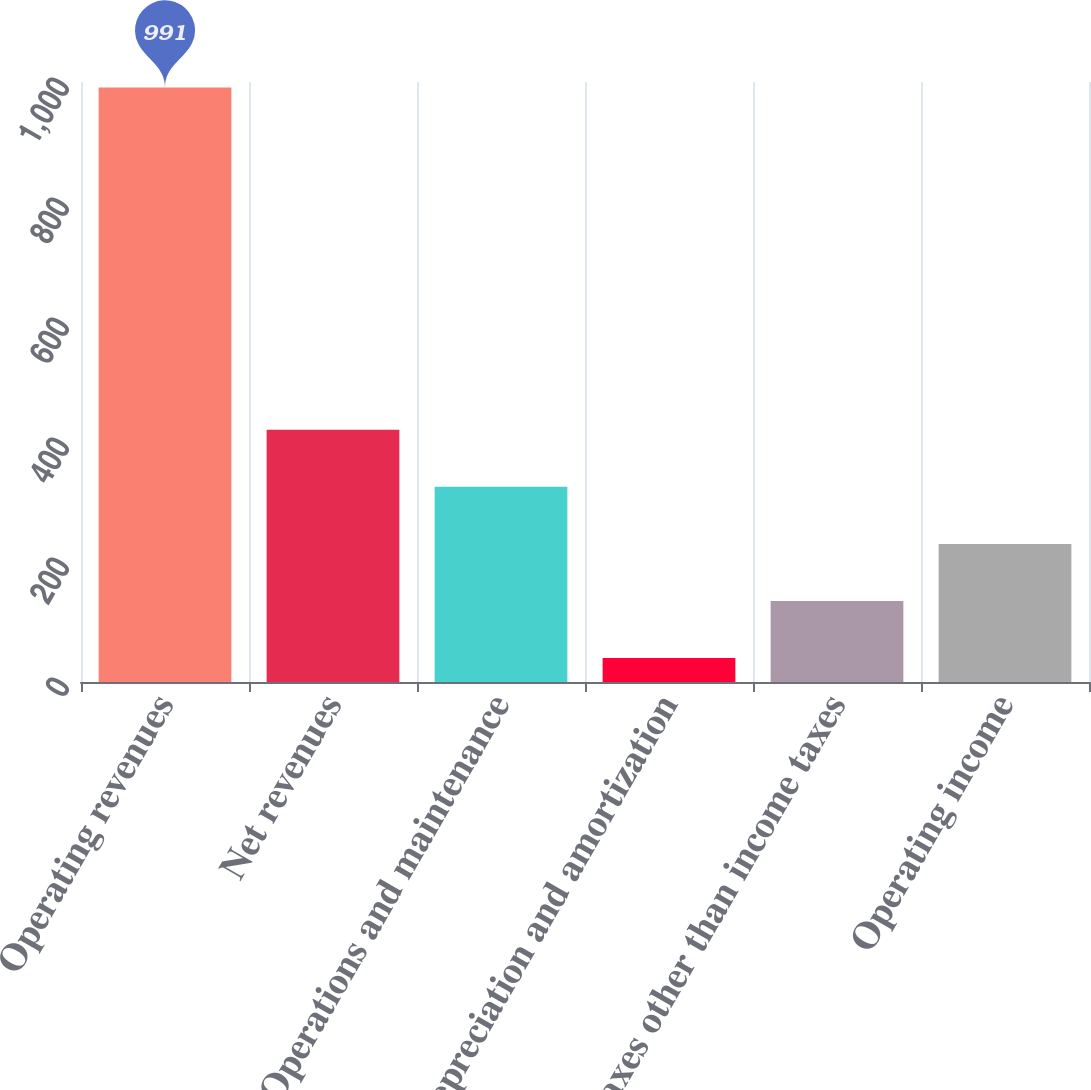Convert chart to OTSL. <chart><loc_0><loc_0><loc_500><loc_500><bar_chart><fcel>Operating revenues<fcel>Net revenues<fcel>Operations and maintenance<fcel>Depreciation and amortization<fcel>Taxes other than income taxes<fcel>Operating income<nl><fcel>991<fcel>420.4<fcel>325.3<fcel>40<fcel>135.1<fcel>230.2<nl></chart> 